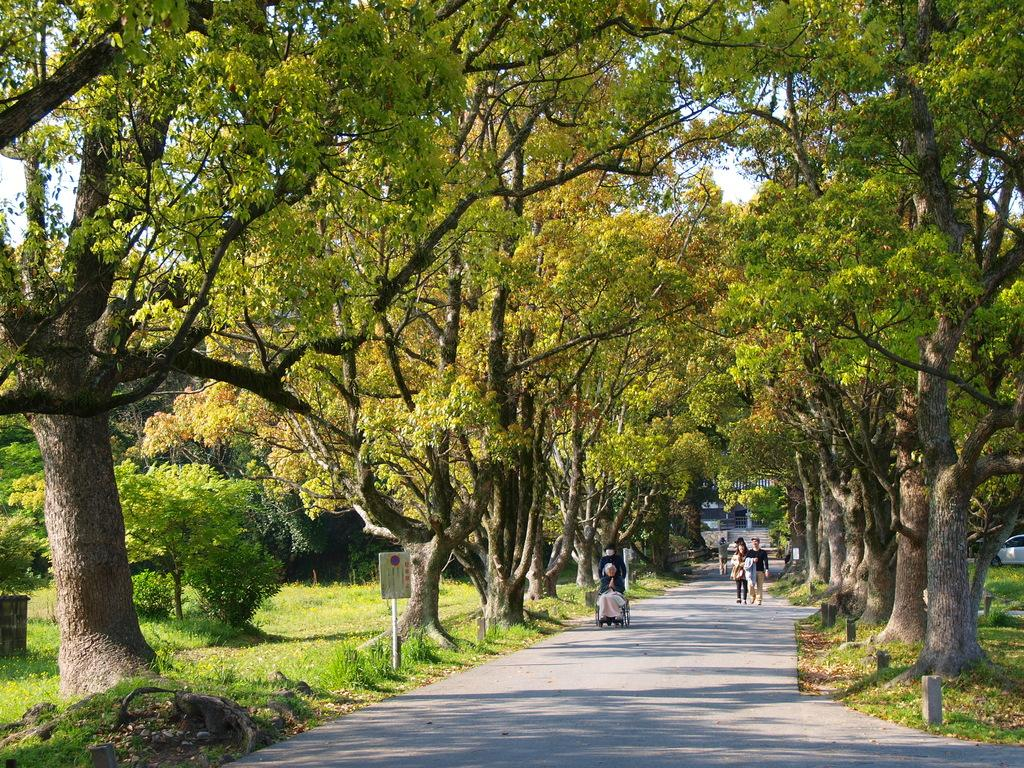What is happening on the road in the image? There are people on the road in the image. What can be seen besides the people on the road? There is a board visible in the image, as well as trees and grass on both sides of the road. Is there any indication of transportation in the image? Yes, a vehicle is visible in the distance. What type of committee can be seen discussing matters in the image? There is no committee present in the image; it features people on the road, a board, trees, grass, and a vehicle in the distance. What is the taste of the airplane in the image? There is no airplane present in the image, so it is not possible to determine its taste. 